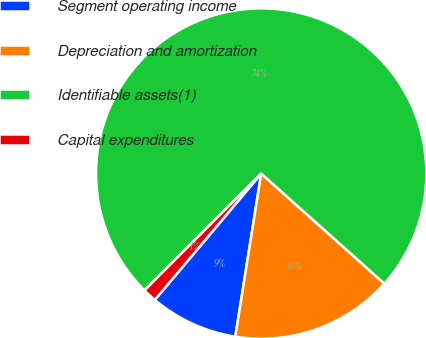<chart> <loc_0><loc_0><loc_500><loc_500><pie_chart><fcel>Segment operating income<fcel>Depreciation and amortization<fcel>Identifiable assets(1)<fcel>Capital expenditures<nl><fcel>8.63%<fcel>15.9%<fcel>74.11%<fcel>1.35%<nl></chart> 